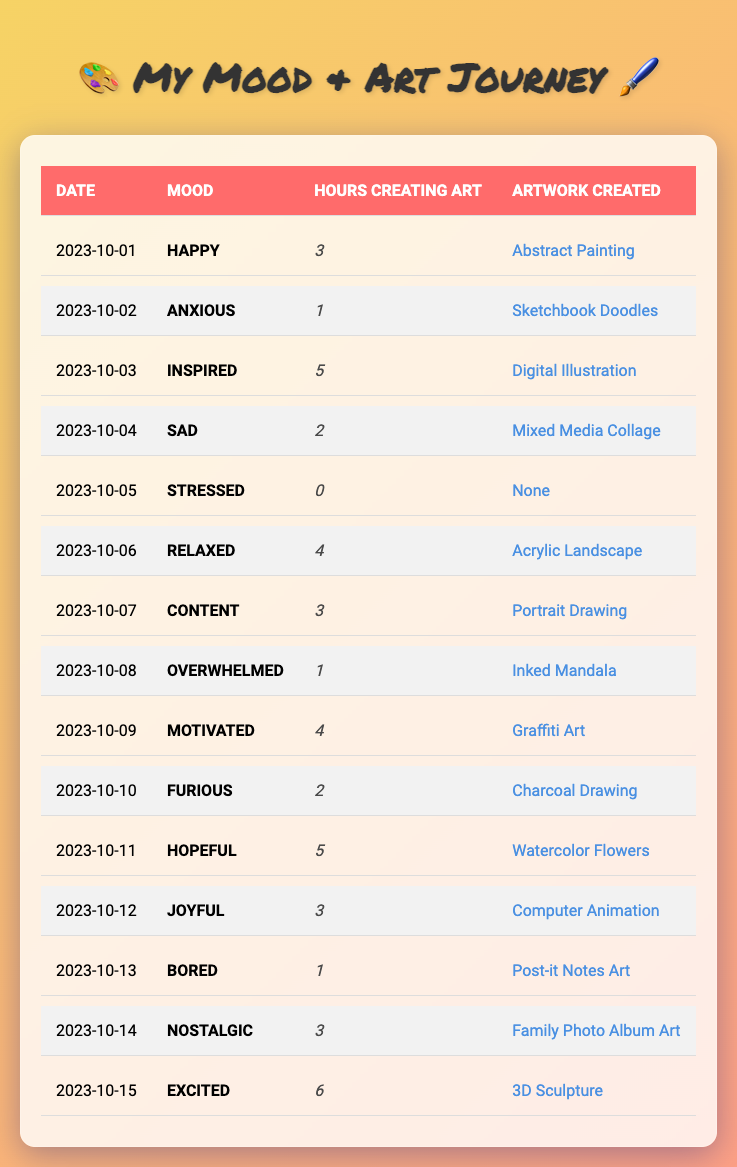What mood was recorded on 2023-10-03? The table shows that the mood recorded on 2023-10-03 is "Inspired."
Answer: Inspired How many hours did the artist spend creating art on 2023-10-11? According to the table, the artist spent 5 hours creating art on 2023-10-11.
Answer: 5 What artwork was created on the day the artist felt motivated? The artwork created on the day the artist felt motivated (2023-10-09) is "Graffiti Art."
Answer: Graffiti Art Which day had the least hours spent creating art? Looking at the data, the day with the least hours spent creating art is 2023-10-05, with 0 hours.
Answer: 2023-10-05 What is the total number of hours spent creating art from October 1 to October 15? We can sum the hours spent creating art for each day from October 1 to October 15, which equals 3 + 1 + 5 + 2 + 0 + 4 + 3 + 1 + 4 + 2 + 5 + 3 + 1 + 3 + 6 = 43.
Answer: 43 On how many days was the artist in a "Happy" mood? The table lists "Happy" as the mood on 2023-10-01 and there are no other instances of "Happy," so it was recorded on only 1 day.
Answer: 1 Was there any day where the artist did not create any artwork? Yes, there was a day where the artist did not create any artwork, which is on 2023-10-05.
Answer: Yes What was the mood on the day with the most hours spent creating art? The day with the most hours spent creating art is 2023-10-15 with 6 hours, and the mood on that day was "Excited."
Answer: Excited What is the average number of hours spent creating art on days when the mood was "Inspired" or "Hopeful"? The hours on those days are 5 (Inspired) and 5 (Hopeful). To find the average, sum them: 5 + 5 = 10, and divide by the number of instances (2): 10 / 2 = 5.
Answer: 5 Which artwork was created on the day when the artist felt "Sad"? The artwork created on the day the artist felt "Sad" (2023-10-04) is "Mixed Media Collage."
Answer: Mixed Media Collage How many different moods were recorded that had a correlation with at least 3 hours of art creation? The moods with at least 3 hours of art creation are "Happy," "Content," "Relaxed," "Inspired," "Hopeful," and "Excited." This gives us a total of 6 different moods.
Answer: 6 Which mood had the most variation in hours spent creating art? The moods "Inspired" and "Excited" had higher hours (5 and 6 respectively) while "Stressed" had 0 hours, showing significant variation with a difference of 6 hours.
Answer: Inspired and Excited Did the artist create any artwork on the day they felt "Bored"? Yes, the artist created "Post-it Notes Art" on the day they felt "Bored" (2023-10-13).
Answer: Yes 